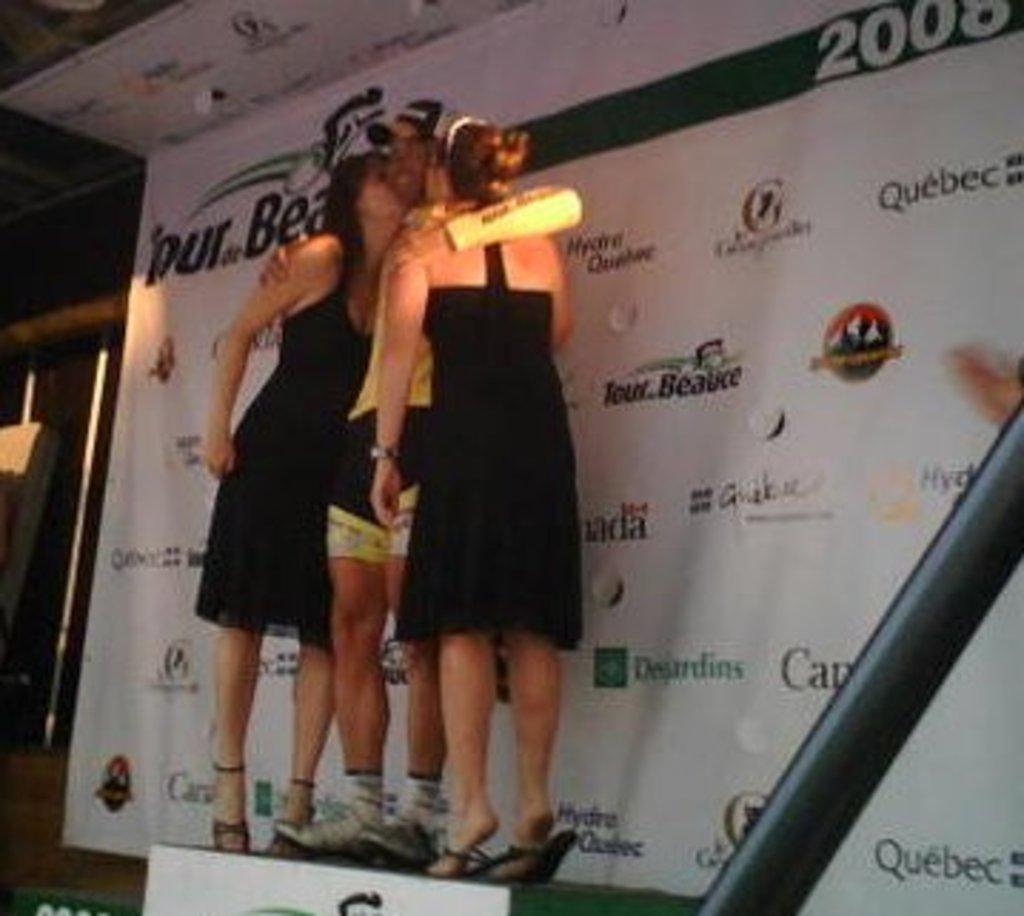Please provide a concise description of this image. In the picture I can see two women and a man standing on the stand. I can see two women kissing a man in the middle. I can see the hoarding on the right side. 